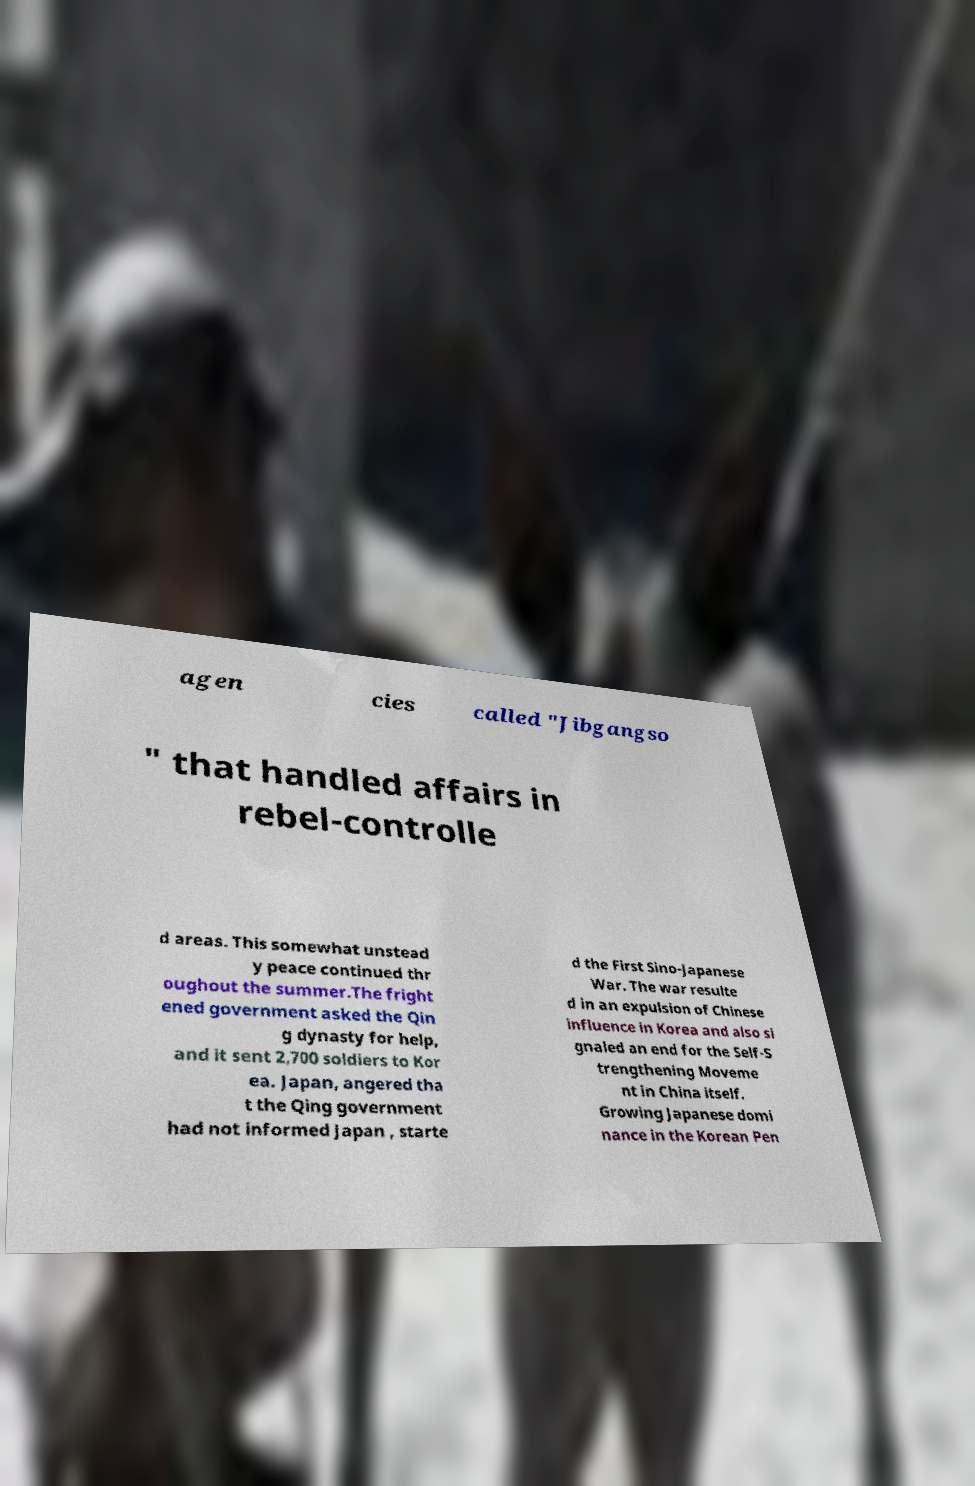For documentation purposes, I need the text within this image transcribed. Could you provide that? agen cies called "Jibgangso " that handled affairs in rebel-controlle d areas. This somewhat unstead y peace continued thr oughout the summer.The fright ened government asked the Qin g dynasty for help, and it sent 2,700 soldiers to Kor ea. Japan, angered tha t the Qing government had not informed Japan , starte d the First Sino-Japanese War. The war resulte d in an expulsion of Chinese influence in Korea and also si gnaled an end for the Self-S trengthening Moveme nt in China itself. Growing Japanese domi nance in the Korean Pen 